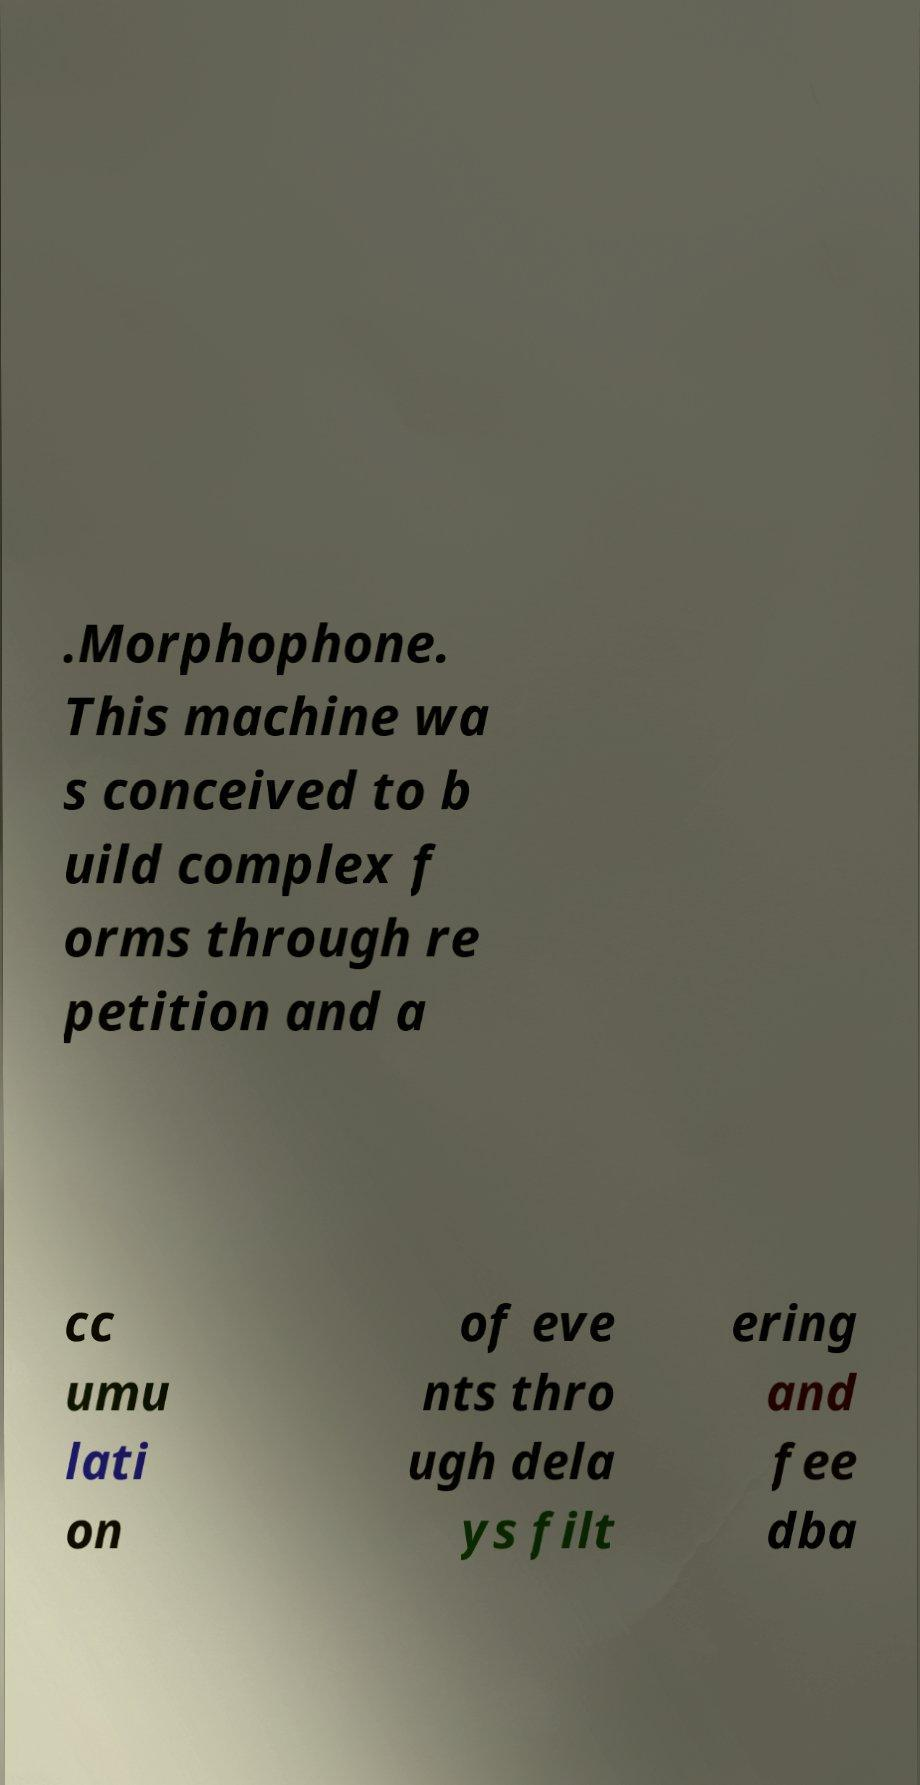What messages or text are displayed in this image? I need them in a readable, typed format. .Morphophone. This machine wa s conceived to b uild complex f orms through re petition and a cc umu lati on of eve nts thro ugh dela ys filt ering and fee dba 